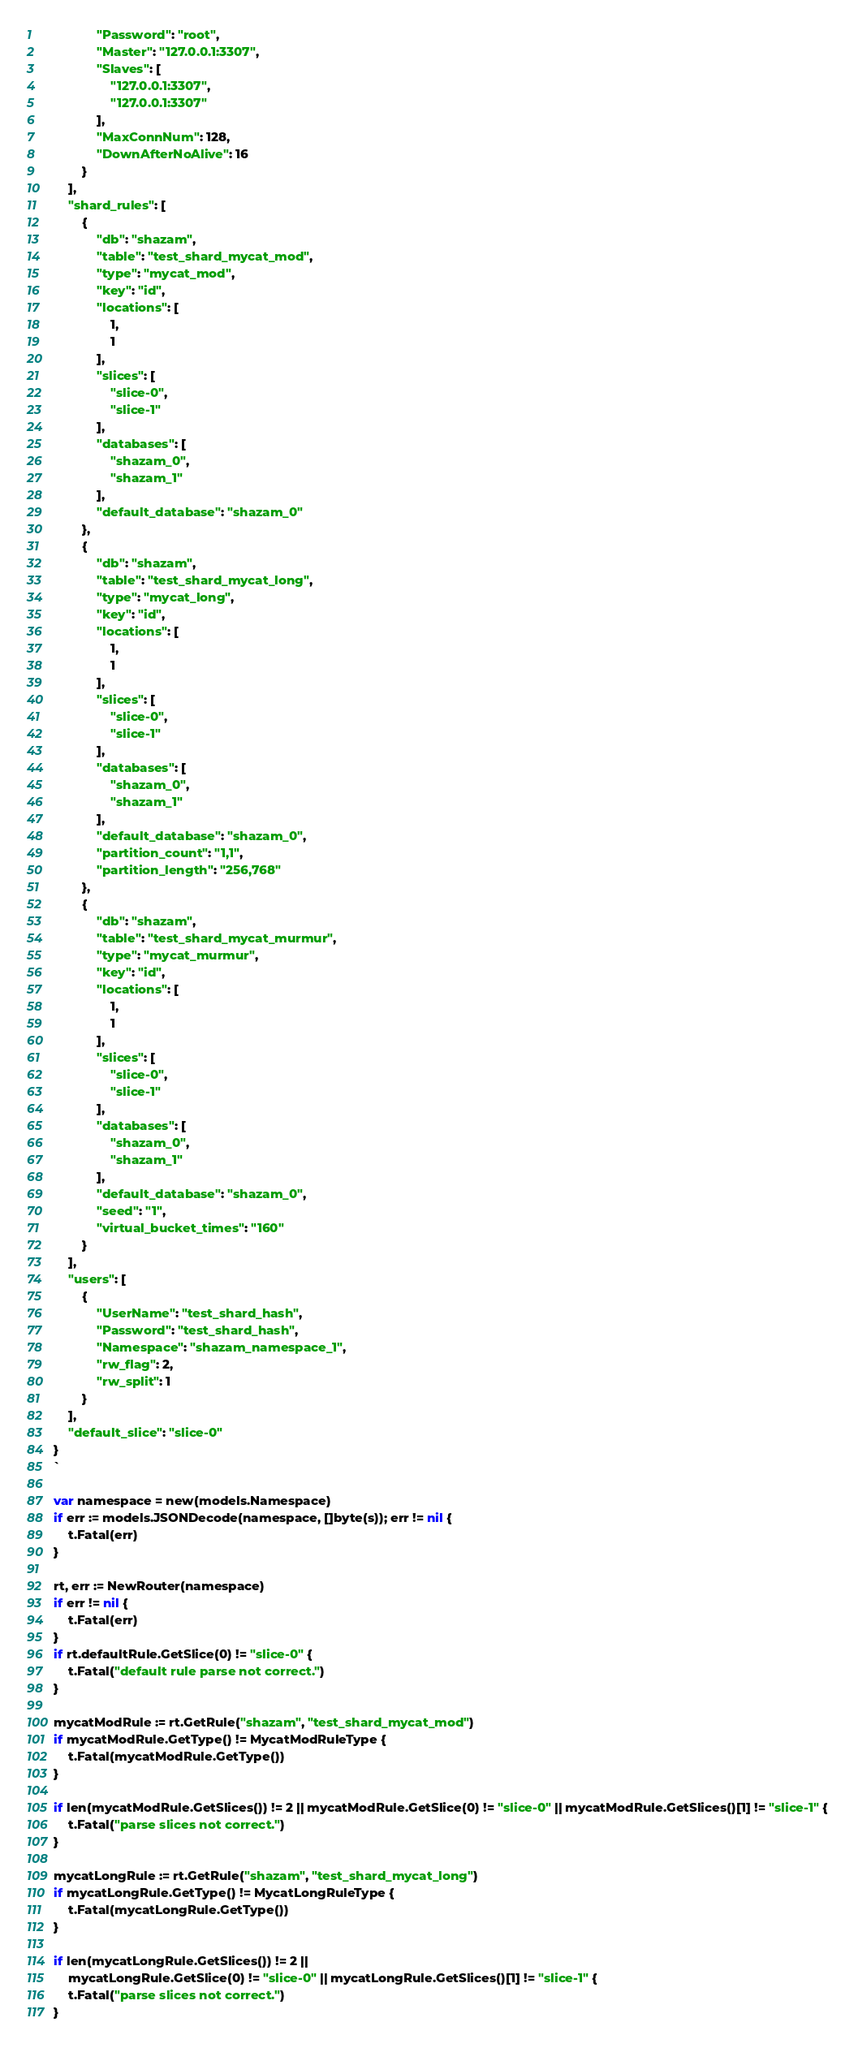Convert code to text. <code><loc_0><loc_0><loc_500><loc_500><_Go_>				"Password": "root",
				"Master": "127.0.0.1:3307",
				"Slaves": [
					"127.0.0.1:3307",
					"127.0.0.1:3307"
				],
				"MaxConnNum": 128,
				"DownAfterNoAlive": 16
			}
		],
		"shard_rules": [
			{
				"db": "shazam",
				"table": "test_shard_mycat_mod",
				"type": "mycat_mod",
				"key": "id",
				"locations": [
					1,
					1
				],
				"slices": [
					"slice-0",
					"slice-1"
				],
				"databases": [
					"shazam_0",
					"shazam_1"
				],
				"default_database": "shazam_0"
			},
			{
				"db": "shazam",
				"table": "test_shard_mycat_long",
				"type": "mycat_long",
				"key": "id",
				"locations": [
					1,
					1
				],
				"slices": [
					"slice-0",
					"slice-1"
				],
				"databases": [
					"shazam_0",
					"shazam_1"
				],
				"default_database": "shazam_0",
				"partition_count": "1,1",
				"partition_length": "256,768"
			},
			{
				"db": "shazam",
				"table": "test_shard_mycat_murmur",
				"type": "mycat_murmur",
				"key": "id",
				"locations": [
					1,
					1
				],
				"slices": [
					"slice-0",
					"slice-1"
				],
				"databases": [
					"shazam_0",
					"shazam_1"
				],
				"default_database": "shazam_0",
				"seed": "1",
				"virtual_bucket_times": "160"
			}
		],
		"users": [
			{
				"UserName": "test_shard_hash",
				"Password": "test_shard_hash",
				"Namespace": "shazam_namespace_1",
				"rw_flag": 2,
				"rw_split": 1
			}
		],
		"default_slice": "slice-0"
	}
	`

	var namespace = new(models.Namespace)
	if err := models.JSONDecode(namespace, []byte(s)); err != nil {
		t.Fatal(err)
	}

	rt, err := NewRouter(namespace)
	if err != nil {
		t.Fatal(err)
	}
	if rt.defaultRule.GetSlice(0) != "slice-0" {
		t.Fatal("default rule parse not correct.")
	}

	mycatModRule := rt.GetRule("shazam", "test_shard_mycat_mod")
	if mycatModRule.GetType() != MycatModRuleType {
		t.Fatal(mycatModRule.GetType())
	}

	if len(mycatModRule.GetSlices()) != 2 || mycatModRule.GetSlice(0) != "slice-0" || mycatModRule.GetSlices()[1] != "slice-1" {
		t.Fatal("parse slices not correct.")
	}

	mycatLongRule := rt.GetRule("shazam", "test_shard_mycat_long")
	if mycatLongRule.GetType() != MycatLongRuleType {
		t.Fatal(mycatLongRule.GetType())
	}

	if len(mycatLongRule.GetSlices()) != 2 ||
		mycatLongRule.GetSlice(0) != "slice-0" || mycatLongRule.GetSlices()[1] != "slice-1" {
		t.Fatal("parse slices not correct.")
	}
</code> 